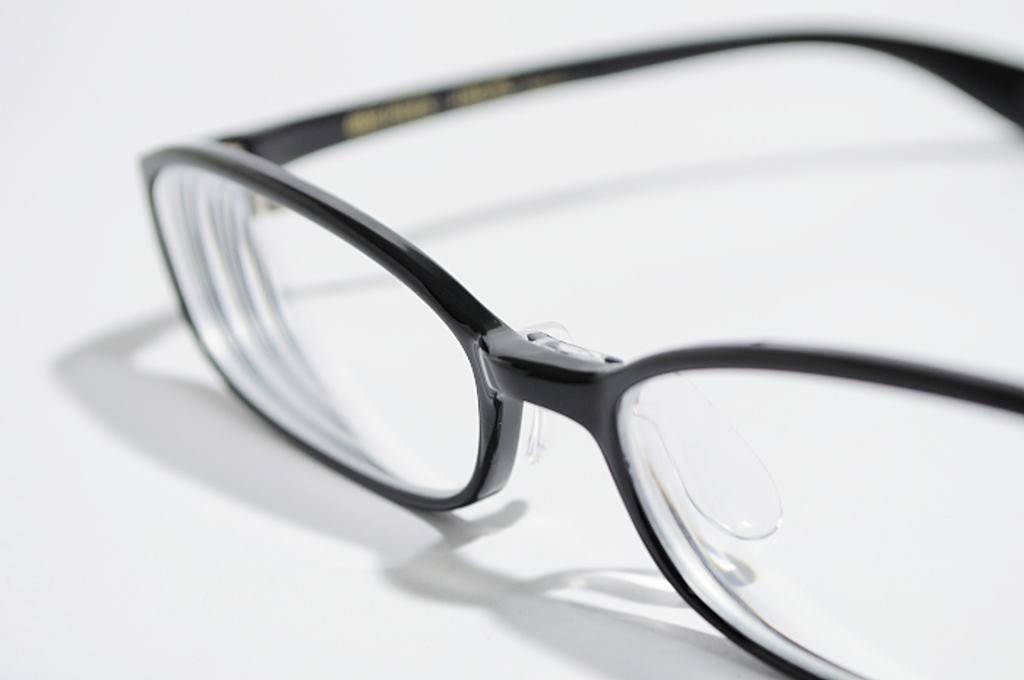What object is present on the white surface in the image? There are spectacles in the image. Can you describe the surface on which the spectacles are placed? The spectacles are on a white surface. What else can be observed in the image besides the spectacles? The shadow of the spectacles is visible in the image. What type of animal can be seen interacting with the spectacles in the image? There is no animal present in the image; it only features spectacles on a white surface and their shadow. 